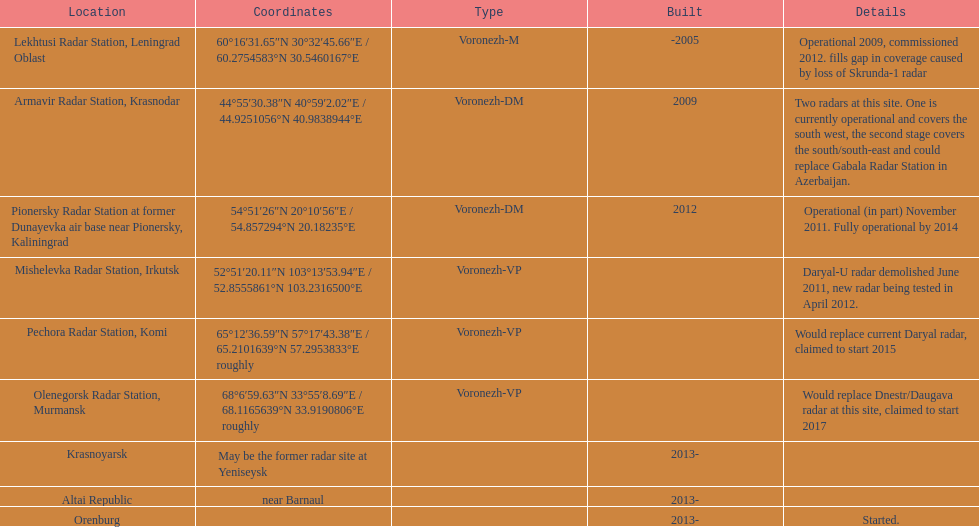In which column are the coordinates that commence with 60 degrees located? 60°16′31.65″N 30°32′45.66″E﻿ / ﻿60.2754583°N 30.5460167°E. What is the site situated in the same row of that specific column? Lekhtusi Radar Station, Leningrad Oblast. 